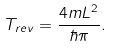<formula> <loc_0><loc_0><loc_500><loc_500>T _ { r e v } = \frac { 4 m L ^ { 2 } } { \hbar { \pi } } .</formula> 